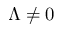Convert formula to latex. <formula><loc_0><loc_0><loc_500><loc_500>\Lambda \neq 0</formula> 